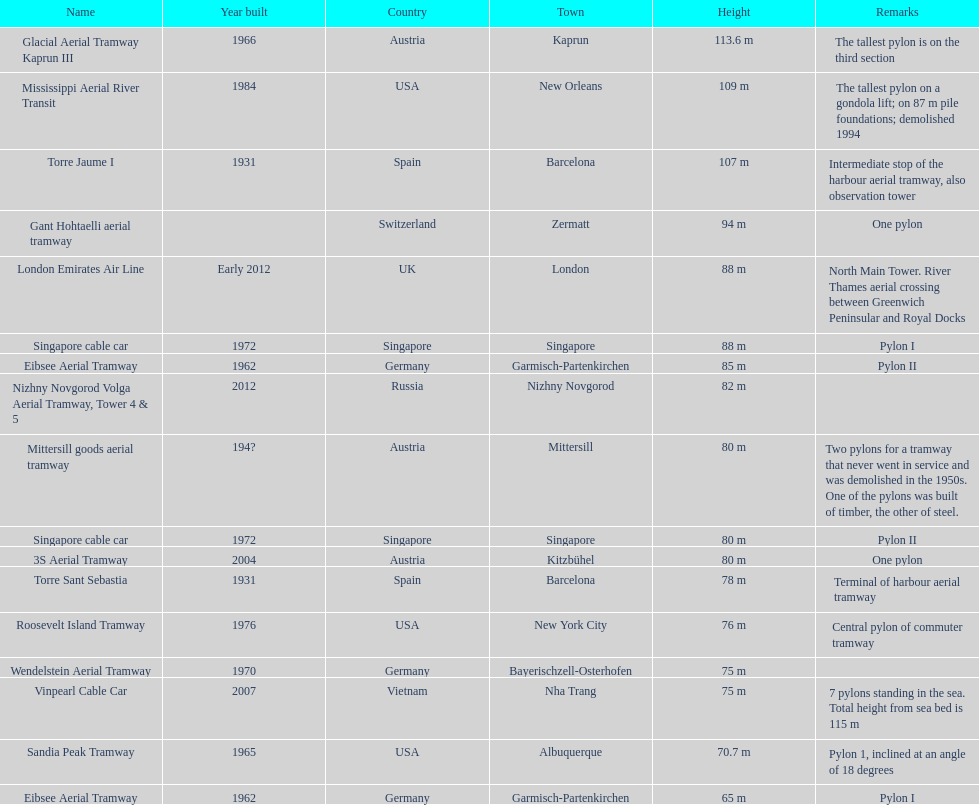Which pylon has the most remarks about it? Mittersill goods aerial tramway. 